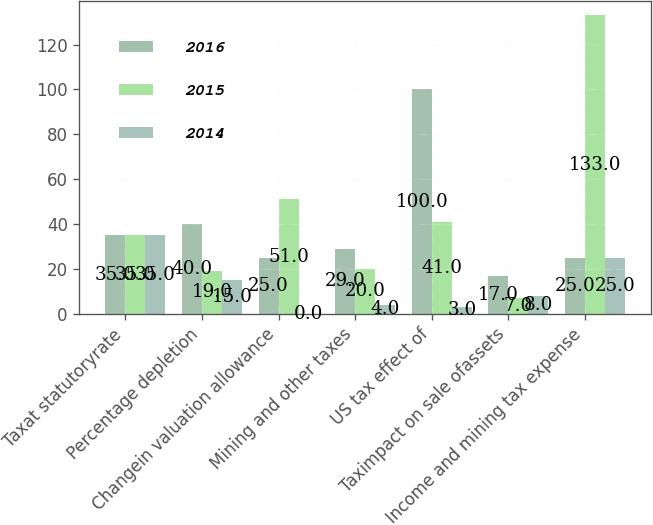Convert chart to OTSL. <chart><loc_0><loc_0><loc_500><loc_500><stacked_bar_chart><ecel><fcel>Taxat statutoryrate<fcel>Percentage depletion<fcel>Changein valuation allowance<fcel>Mining and other taxes<fcel>US tax effect of<fcel>Taximpact on sale ofassets<fcel>Income and mining tax expense<nl><fcel>2016<fcel>35<fcel>40<fcel>25<fcel>29<fcel>100<fcel>17<fcel>25<nl><fcel>2015<fcel>35<fcel>19<fcel>51<fcel>20<fcel>41<fcel>7<fcel>133<nl><fcel>2014<fcel>35<fcel>15<fcel>0<fcel>4<fcel>3<fcel>8<fcel>25<nl></chart> 